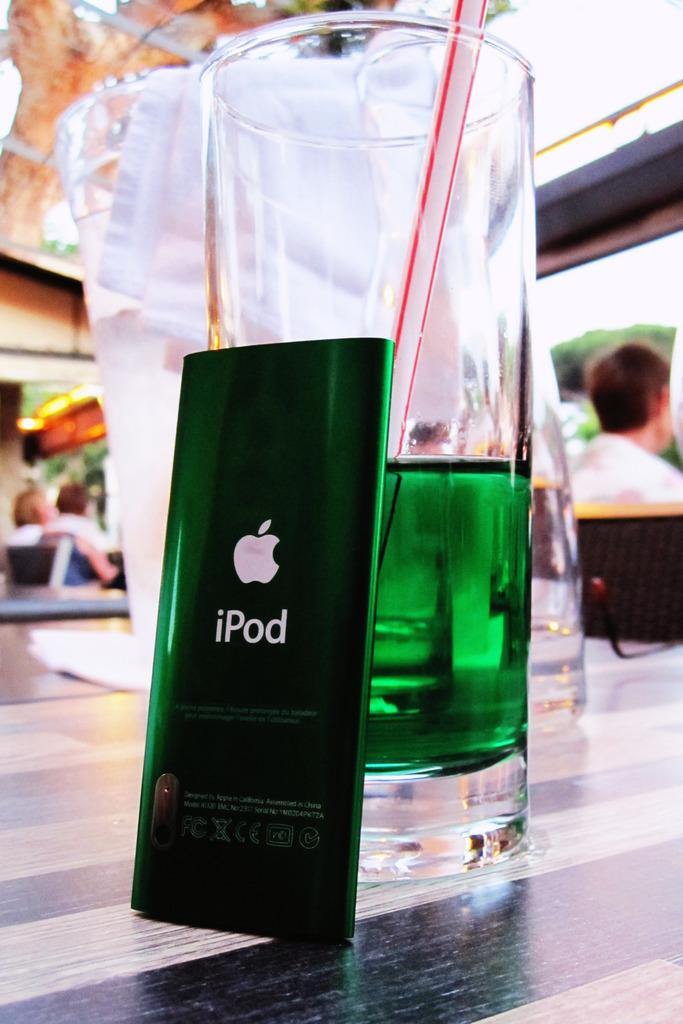What brand of device is green?
Your answer should be compact. Ipod. 